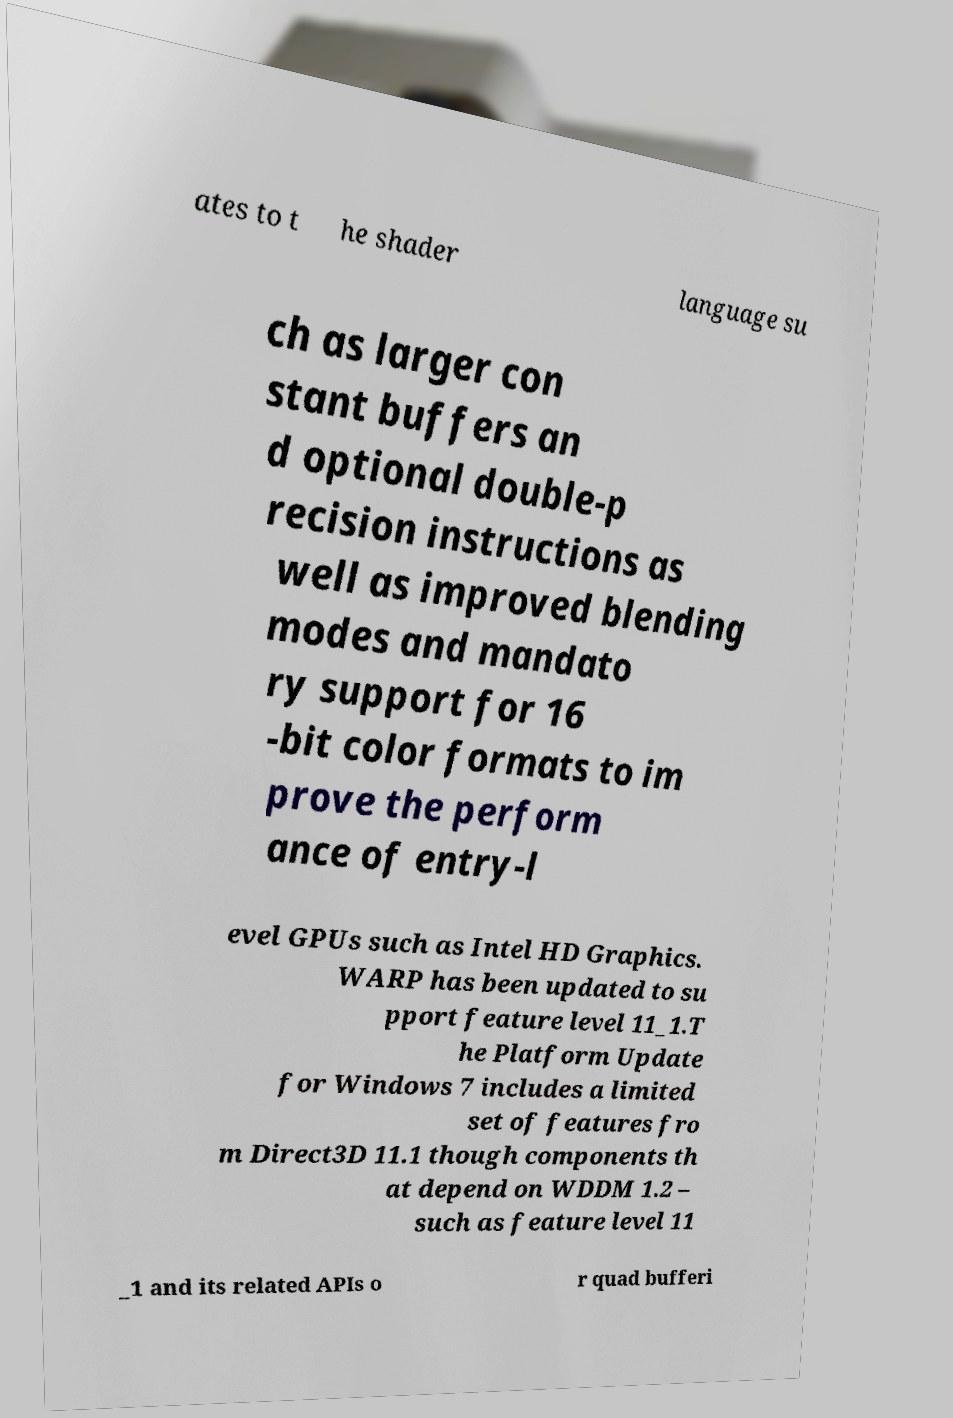Please identify and transcribe the text found in this image. ates to t he shader language su ch as larger con stant buffers an d optional double-p recision instructions as well as improved blending modes and mandato ry support for 16 -bit color formats to im prove the perform ance of entry-l evel GPUs such as Intel HD Graphics. WARP has been updated to su pport feature level 11_1.T he Platform Update for Windows 7 includes a limited set of features fro m Direct3D 11.1 though components th at depend on WDDM 1.2 – such as feature level 11 _1 and its related APIs o r quad bufferi 